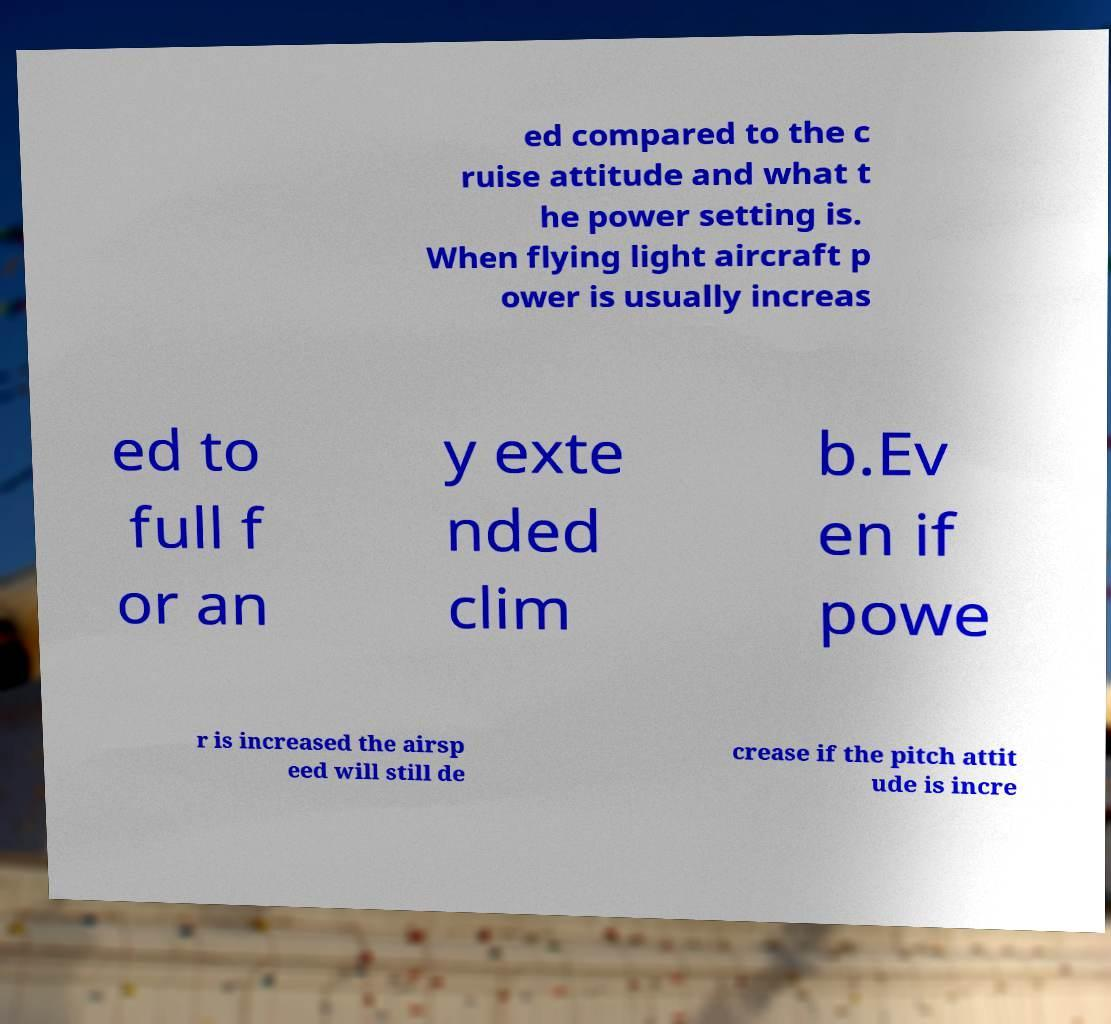Please read and relay the text visible in this image. What does it say? ed compared to the c ruise attitude and what t he power setting is. When flying light aircraft p ower is usually increas ed to full f or an y exte nded clim b.Ev en if powe r is increased the airsp eed will still de crease if the pitch attit ude is incre 